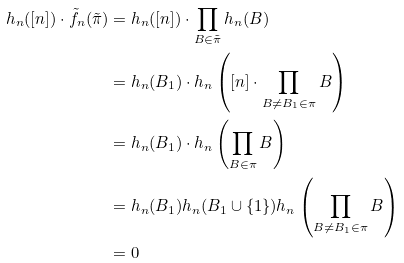Convert formula to latex. <formula><loc_0><loc_0><loc_500><loc_500>h _ { n } ( [ n ] ) \cdot \tilde { f } _ { n } ( \tilde { \pi } ) & = h _ { n } ( [ n ] ) \cdot \prod _ { B \in \tilde { \pi } } h _ { n } ( B ) \\ & = h _ { n } ( B _ { 1 } ) \cdot h _ { n } \left ( [ n ] \cdot \prod _ { B \neq B _ { 1 } \in \pi } B \right ) \\ & = h _ { n } ( B _ { 1 } ) \cdot h _ { n } \left ( \prod _ { B \in \pi } B \right ) \\ & = h _ { n } ( B _ { 1 } ) h _ { n } ( B _ { 1 } \cup \{ 1 \} ) h _ { n } \left ( \prod _ { B \neq B _ { 1 } \in \pi } B \right ) \\ & = 0</formula> 